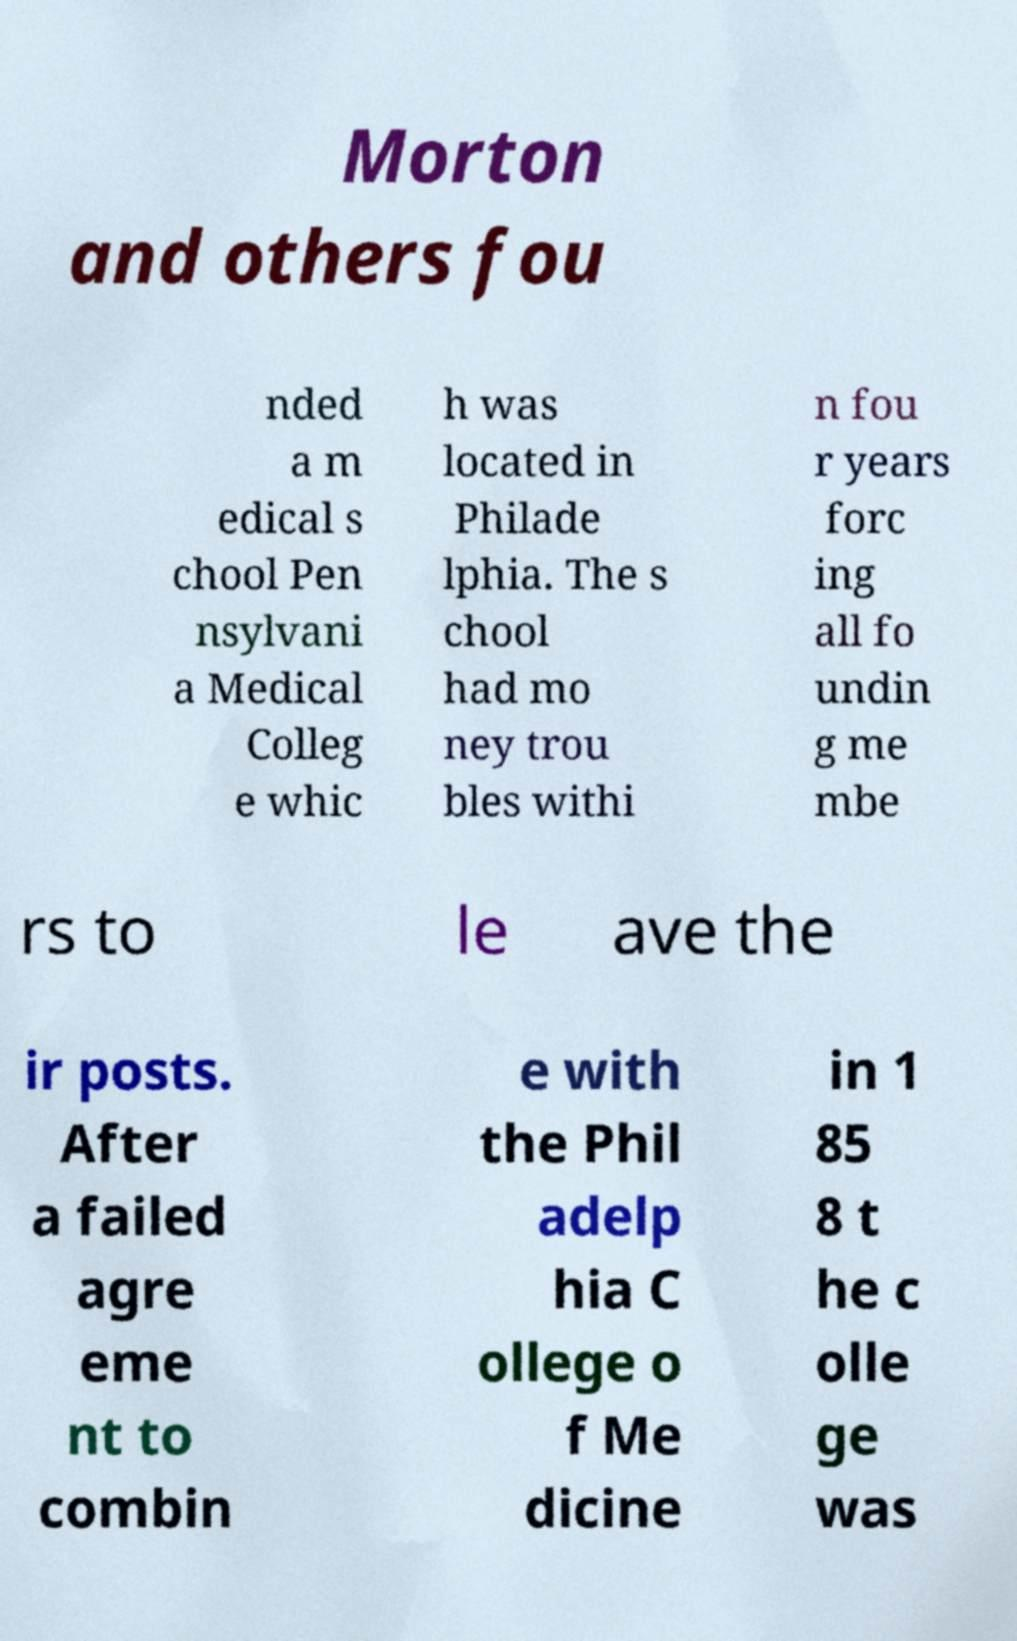There's text embedded in this image that I need extracted. Can you transcribe it verbatim? Morton and others fou nded a m edical s chool Pen nsylvani a Medical Colleg e whic h was located in Philade lphia. The s chool had mo ney trou bles withi n fou r years forc ing all fo undin g me mbe rs to le ave the ir posts. After a failed agre eme nt to combin e with the Phil adelp hia C ollege o f Me dicine in 1 85 8 t he c olle ge was 